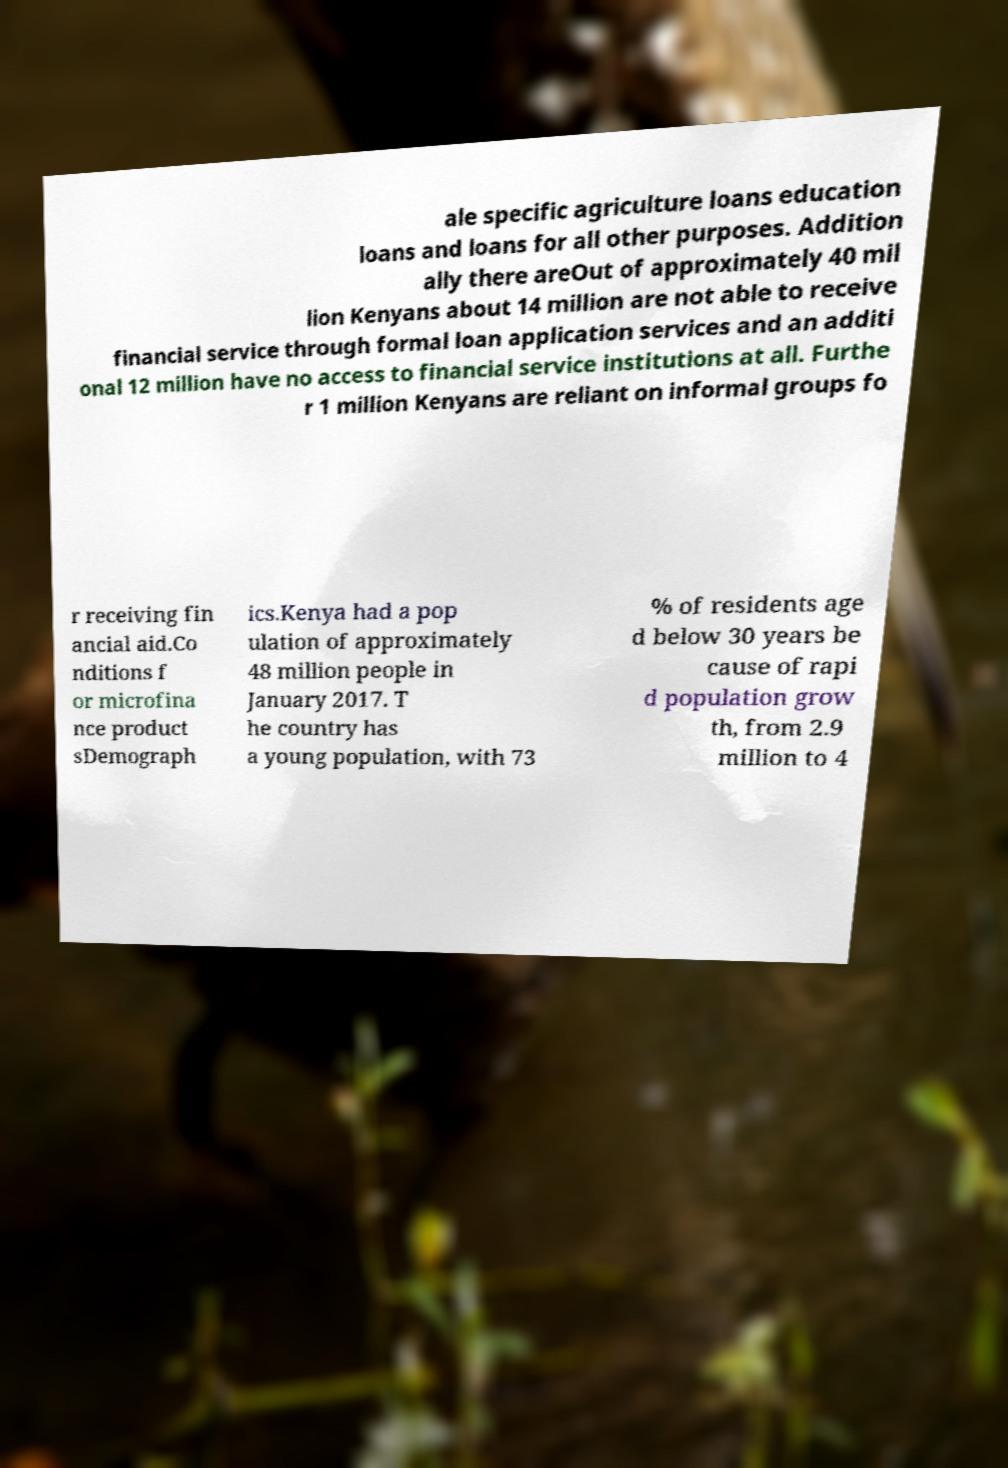I need the written content from this picture converted into text. Can you do that? ale specific agriculture loans education loans and loans for all other purposes. Addition ally there areOut of approximately 40 mil lion Kenyans about 14 million are not able to receive financial service through formal loan application services and an additi onal 12 million have no access to financial service institutions at all. Furthe r 1 million Kenyans are reliant on informal groups fo r receiving fin ancial aid.Co nditions f or microfina nce product sDemograph ics.Kenya had a pop ulation of approximately 48 million people in January 2017. T he country has a young population, with 73 % of residents age d below 30 years be cause of rapi d population grow th, from 2.9 million to 4 